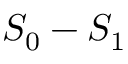<formula> <loc_0><loc_0><loc_500><loc_500>S _ { 0 } - S _ { 1 }</formula> 